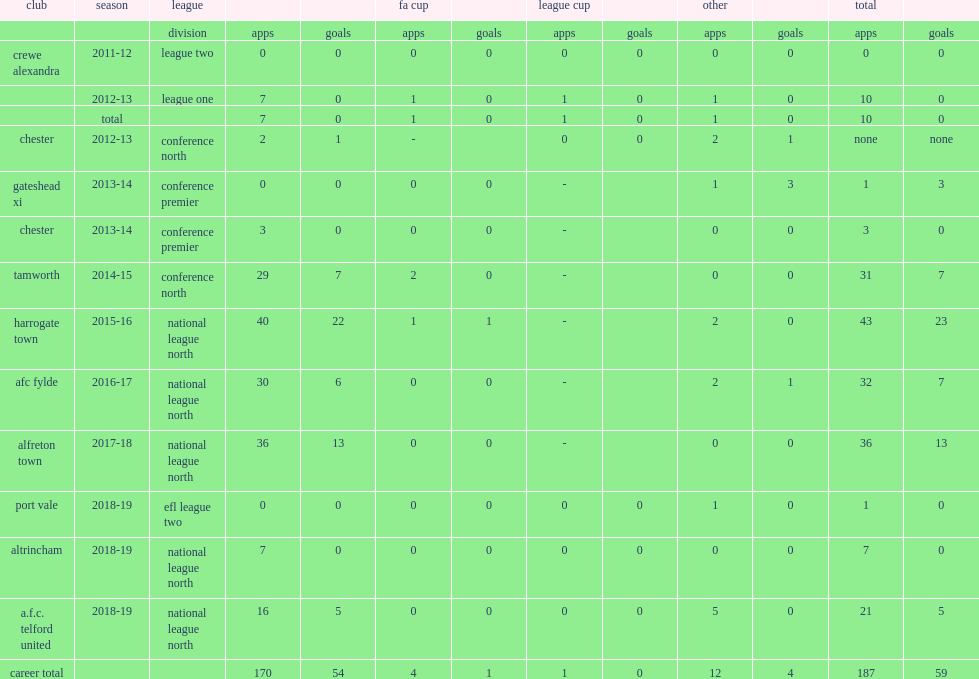Give me the full table as a dictionary. {'header': ['club', 'season', 'league', '', '', 'fa cup', '', 'league cup', '', 'other', '', 'total', ''], 'rows': [['', '', 'division', 'apps', 'goals', 'apps', 'goals', 'apps', 'goals', 'apps', 'goals', 'apps', 'goals'], ['crewe alexandra', '2011-12', 'league two', '0', '0', '0', '0', '0', '0', '0', '0', '0', '0'], ['', '2012-13', 'league one', '7', '0', '1', '0', '1', '0', '1', '0', '10', '0'], ['', 'total', '', '7', '0', '1', '0', '1', '0', '1', '0', '10', '0'], ['chester', '2012-13', 'conference north', '2', '1', '-', '', '0', '0', '2', '1', 'none', 'none'], ['gateshead xi', '2013-14', 'conference premier', '0', '0', '0', '0', '-', '', '1', '3', '1', '3'], ['chester', '2013-14', 'conference premier', '3', '0', '0', '0', '-', '', '0', '0', '3', '0'], ['tamworth', '2014-15', 'conference north', '29', '7', '2', '0', '-', '', '0', '0', '31', '7'], ['harrogate town', '2015-16', 'national league north', '40', '22', '1', '1', '-', '', '2', '0', '43', '23'], ['afc fylde', '2016-17', 'national league north', '30', '6', '0', '0', '-', '', '2', '1', '32', '7'], ['alfreton town', '2017-18', 'national league north', '36', '13', '0', '0', '-', '', '0', '0', '36', '13'], ['port vale', '2018-19', 'efl league two', '0', '0', '0', '0', '0', '0', '1', '0', '1', '0'], ['altrincham', '2018-19', 'national league north', '7', '0', '0', '0', '0', '0', '0', '0', '7', '0'], ['a.f.c. telford united', '2018-19', 'national league north', '16', '5', '0', '0', '0', '0', '5', '0', '21', '5'], ['career total', '', '', '170', '54', '4', '1', '1', '0', '12', '4', '187', '59']]} In the 2015-16 season, which league did brendon daniels join harrogate town in? National league north. 